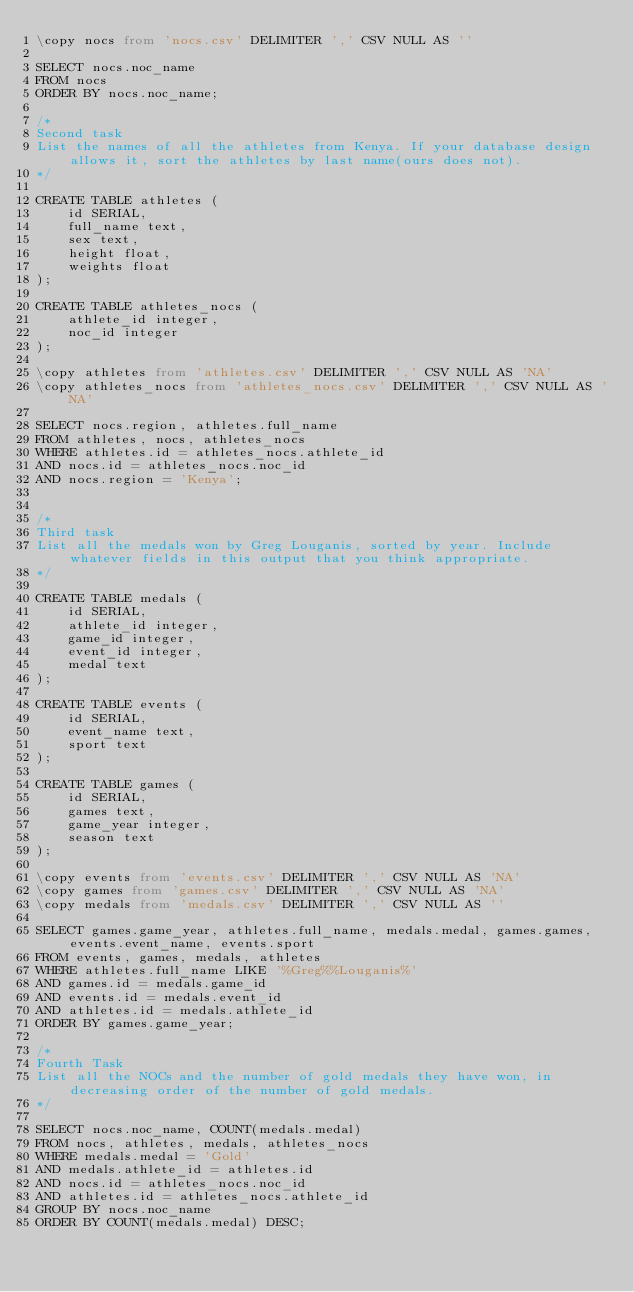Convert code to text. <code><loc_0><loc_0><loc_500><loc_500><_SQL_>\copy nocs from 'nocs.csv' DELIMITER ',' CSV NULL AS ''

SELECT nocs.noc_name
FROM nocs
ORDER BY nocs.noc_name;

/* 
Second task
List the names of all the athletes from Kenya. If your database design allows it, sort the athletes by last name(ours does not).
*/

CREATE TABLE athletes (
    id SERIAL,
    full_name text,
    sex text,
    height float,
    weights float
);

CREATE TABLE athletes_nocs (
    athlete_id integer,
    noc_id integer
);

\copy athletes from 'athletes.csv' DELIMITER ',' CSV NULL AS 'NA'
\copy athletes_nocs from 'athletes_nocs.csv' DELIMITER ',' CSV NULL AS 'NA'

SELECT nocs.region, athletes.full_name
FROM athletes, nocs, athletes_nocs
WHERE athletes.id = athletes_nocs.athlete_id
AND nocs.id = athletes_nocs.noc_id
AND nocs.region = 'Kenya';


/*
Third task
List all the medals won by Greg Louganis, sorted by year. Include whatever fields in this output that you think appropriate.
*/

CREATE TABLE medals (
    id SERIAL,
    athlete_id integer,
    game_id integer,
    event_id integer,
    medal text
);

CREATE TABLE events (
    id SERIAL,
    event_name text,
    sport text
);

CREATE TABLE games (
    id SERIAL,
    games text,
    game_year integer,
    season text
);

\copy events from 'events.csv' DELIMITER ',' CSV NULL AS 'NA'
\copy games from 'games.csv' DELIMITER ',' CSV NULL AS 'NA'
\copy medals from 'medals.csv' DELIMITER ',' CSV NULL AS ''

SELECT games.game_year, athletes.full_name, medals.medal, games.games, events.event_name, events.sport
FROM events, games, medals, athletes
WHERE athletes.full_name LIKE '%Greg%%Louganis%'
AND games.id = medals.game_id
AND events.id = medals.event_id
AND athletes.id = medals.athlete_id
ORDER BY games.game_year;

/*
Fourth Task
List all the NOCs and the number of gold medals they have won, in decreasing order of the number of gold medals.
*/

SELECT nocs.noc_name, COUNT(medals.medal)
FROM nocs, athletes, medals, athletes_nocs
WHERE medals.medal = 'Gold'
AND medals.athlete_id = athletes.id
AND nocs.id = athletes_nocs.noc_id
AND athletes.id = athletes_nocs.athlete_id
GROUP BY nocs.noc_name
ORDER BY COUNT(medals.medal) DESC;
</code> 